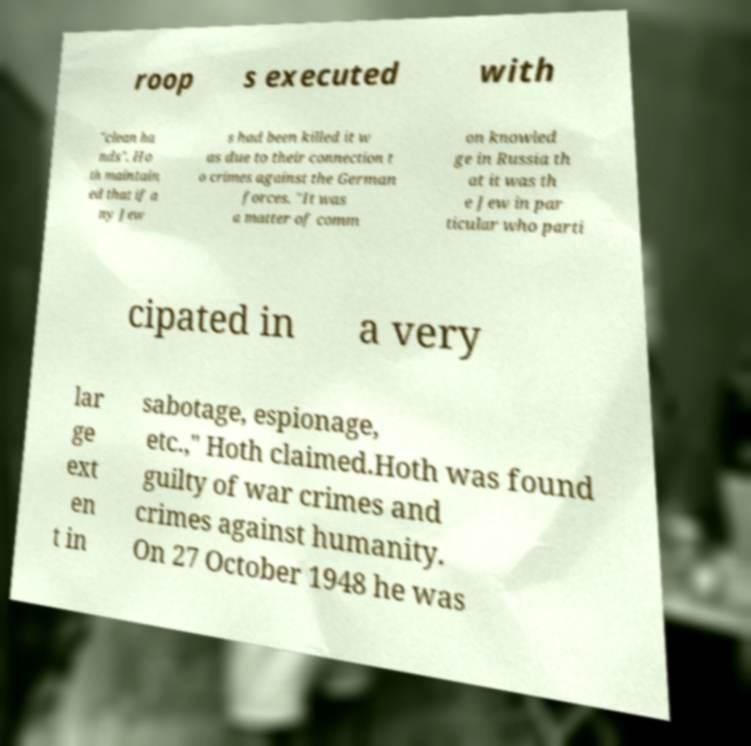Can you accurately transcribe the text from the provided image for me? roop s executed with "clean ha nds". Ho th maintain ed that if a ny Jew s had been killed it w as due to their connection t o crimes against the German forces. "It was a matter of comm on knowled ge in Russia th at it was th e Jew in par ticular who parti cipated in a very lar ge ext en t in sabotage, espionage, etc.," Hoth claimed.Hoth was found guilty of war crimes and crimes against humanity. On 27 October 1948 he was 